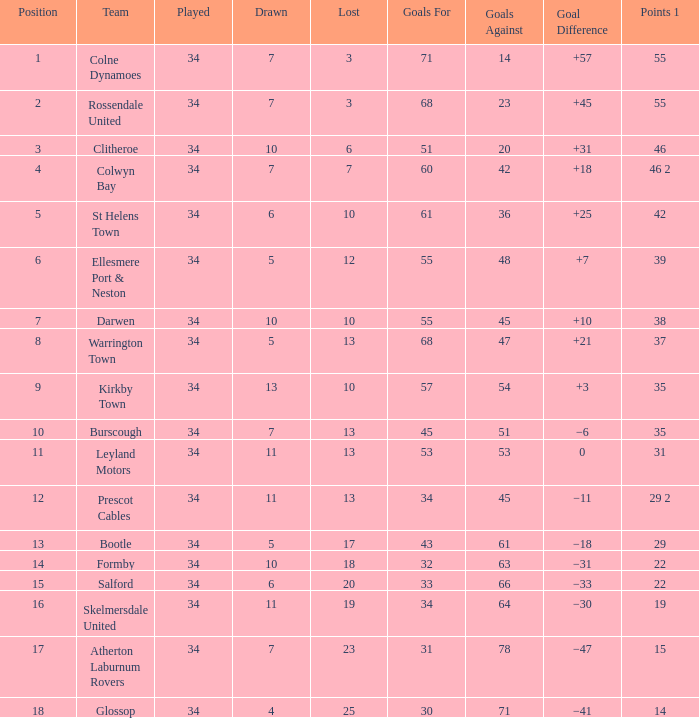How many drawn feature a lost smaller than 25, and a goal difference of +7, and a played larger than 34? 0.0. 